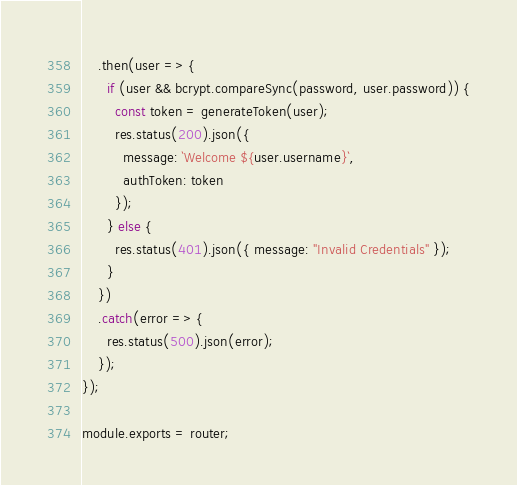Convert code to text. <code><loc_0><loc_0><loc_500><loc_500><_JavaScript_>    .then(user => {
      if (user && bcrypt.compareSync(password, user.password)) {
        const token = generateToken(user);
        res.status(200).json({
          message: `Welcome ${user.username}`,
          authToken: token
        });
      } else {
        res.status(401).json({ message: "Invalid Credentials" });
      }
    })
    .catch(error => {
      res.status(500).json(error);
    });
});

module.exports = router;
</code> 